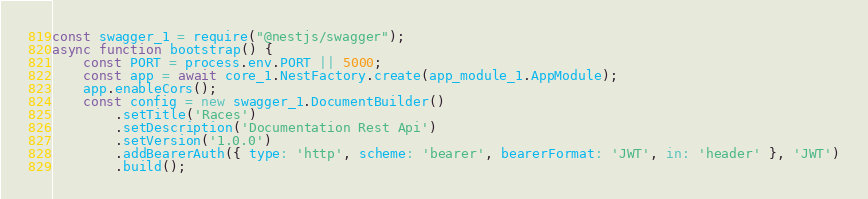Convert code to text. <code><loc_0><loc_0><loc_500><loc_500><_JavaScript_>const swagger_1 = require("@nestjs/swagger");
async function bootstrap() {
    const PORT = process.env.PORT || 5000;
    const app = await core_1.NestFactory.create(app_module_1.AppModule);
    app.enableCors();
    const config = new swagger_1.DocumentBuilder()
        .setTitle('Races')
        .setDescription('Documentation Rest Api')
        .setVersion('1.0.0')
        .addBearerAuth({ type: 'http', scheme: 'bearer', bearerFormat: 'JWT', in: 'header' }, 'JWT')
        .build();</code> 